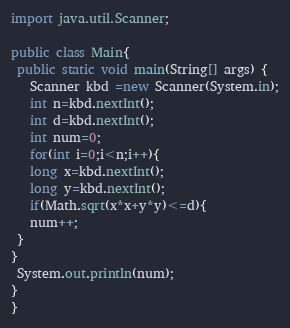Convert code to text. <code><loc_0><loc_0><loc_500><loc_500><_Java_>import java.util.Scanner;

public class Main{
 public static void main(String[] args) {
   Scanner kbd =new Scanner(System.in);
   int n=kbd.nextInt();
   int d=kbd.nextInt();
   int num=0;
   for(int i=0;i<n;i++){
   long x=kbd.nextInt();
   long y=kbd.nextInt();
   if(Math.sqrt(x*x+y*y)<=d){
   num++;
 }
}
 System.out.println(num);
}
}
</code> 